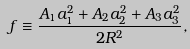Convert formula to latex. <formula><loc_0><loc_0><loc_500><loc_500>f \equiv \frac { A _ { 1 } a _ { 1 } ^ { 2 } + A _ { 2 } a _ { 2 } ^ { 2 } + A _ { 3 } a _ { 3 } ^ { 2 } } { 2 R ^ { 2 } } ,</formula> 